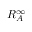Convert formula to latex. <formula><loc_0><loc_0><loc_500><loc_500>R _ { A } ^ { \infty }</formula> 